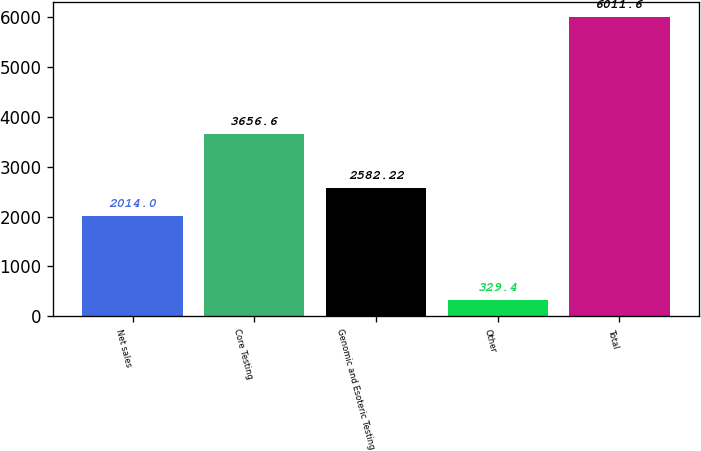Convert chart. <chart><loc_0><loc_0><loc_500><loc_500><bar_chart><fcel>Net sales<fcel>Core Testing<fcel>Genomic and Esoteric Testing<fcel>Other<fcel>Total<nl><fcel>2014<fcel>3656.6<fcel>2582.22<fcel>329.4<fcel>6011.6<nl></chart> 